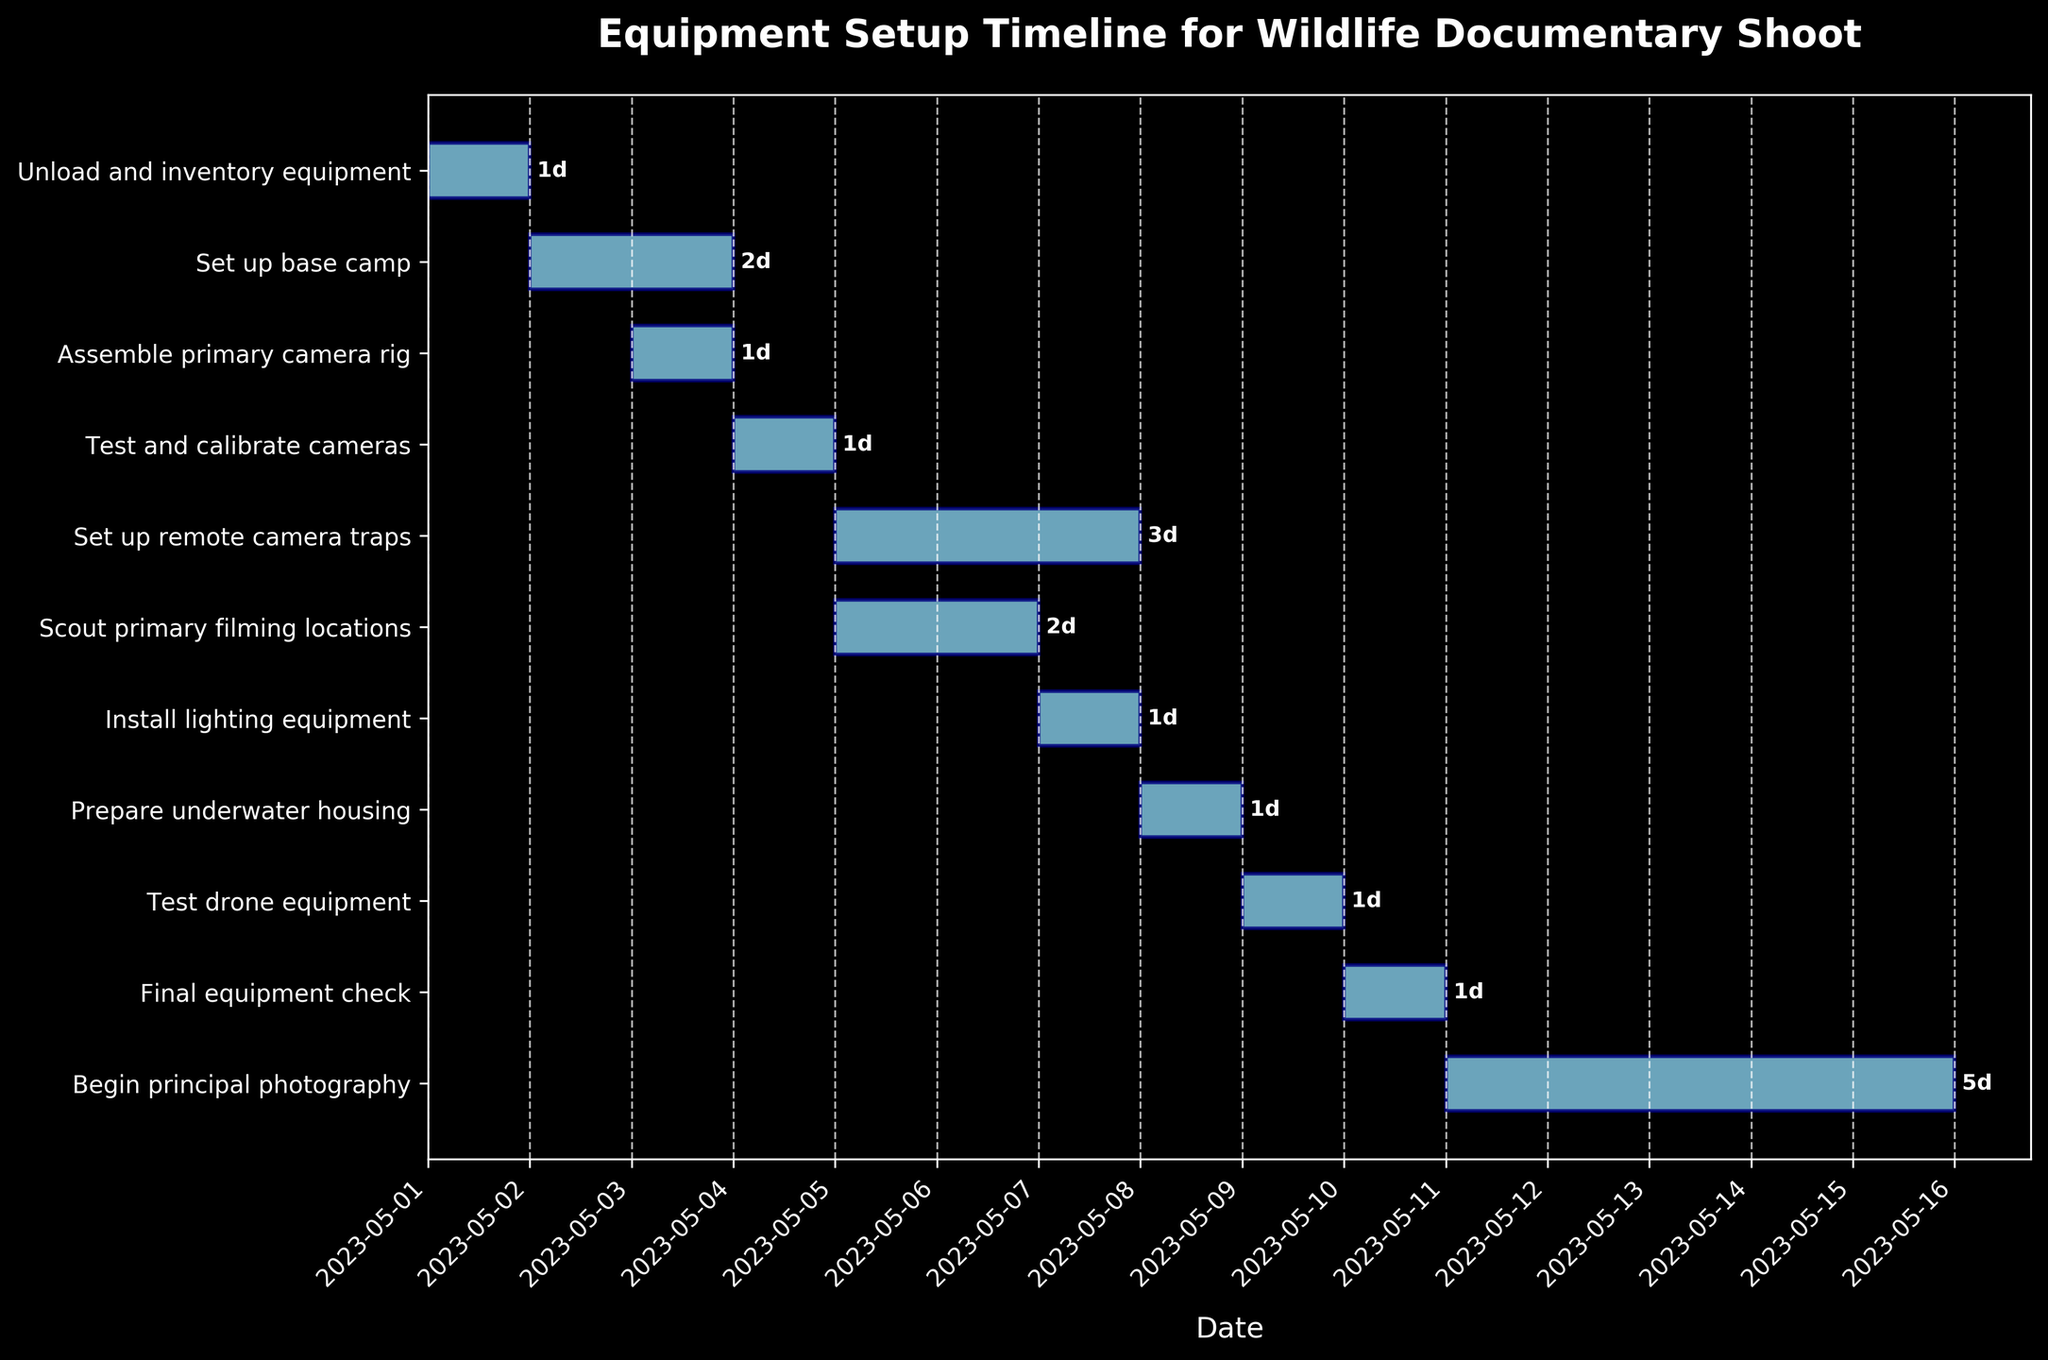what is the title of the plot? The title of the plot is written at the top of the figure. It reads "Equipment Setup Timeline for Wildlife Documentary Shoot".
Answer: Equipment Setup Timeline for Wildlife Documentary Shoot what is the duration for setting up the base camp? By finding the "Set up base camp" task in the y-axis labels and following the gantt bar, we see that its duration is labelled as " 2d".
Answer: 2 days Which task starts on May 3, 2023? To answer, locate the starting dates and check which task begins on May 3, 2023. The "Assemble primary camera rig" task begins on this date.
Answer: Assemble primary camera rig How many tasks have a duration of exactly 1 day? By observing the figure, identify the tasks with bars labelled as " 1d". The tasks are "Unload and inventory equipment", "Assemble primary camera rig", "Test and calibrate cameras", "Install lighting equipment", "Prepare underwater housing", "Test drone equipment", "Final equipment check, and so 7 tasks have a duration of 1 day.
Answer: 7 Which task ends last before principal photography begins? To determine the last task to end before "Begin principal photography", which starts on 2023-05-11, observe the end dates just before this date. The "Final equipment check" ends on 2023-05-10.
Answer: Final equipment check Which task overlaps with the "Scout primary filming locations" task? Check the start and end dates of tasks overlapping with "Scout primary filming locations". "Set up remote camera traps" starting on 2023-05-05 and ending on 2023-05-07 overlaps with it.
Answer: Set up remote camera traps How long is the principal photography scheduled for? Find the "Begin principal photography" task and check the duration label at the end of the bar. It shows " 5d".
Answer: 5 days What is the total duration from the first to the last task? The first task starts on 2023-05-01 and the last task ends on 2023-05-16. Calculate the duration between these two dates. The total is 15 days.
Answer: 15 days 